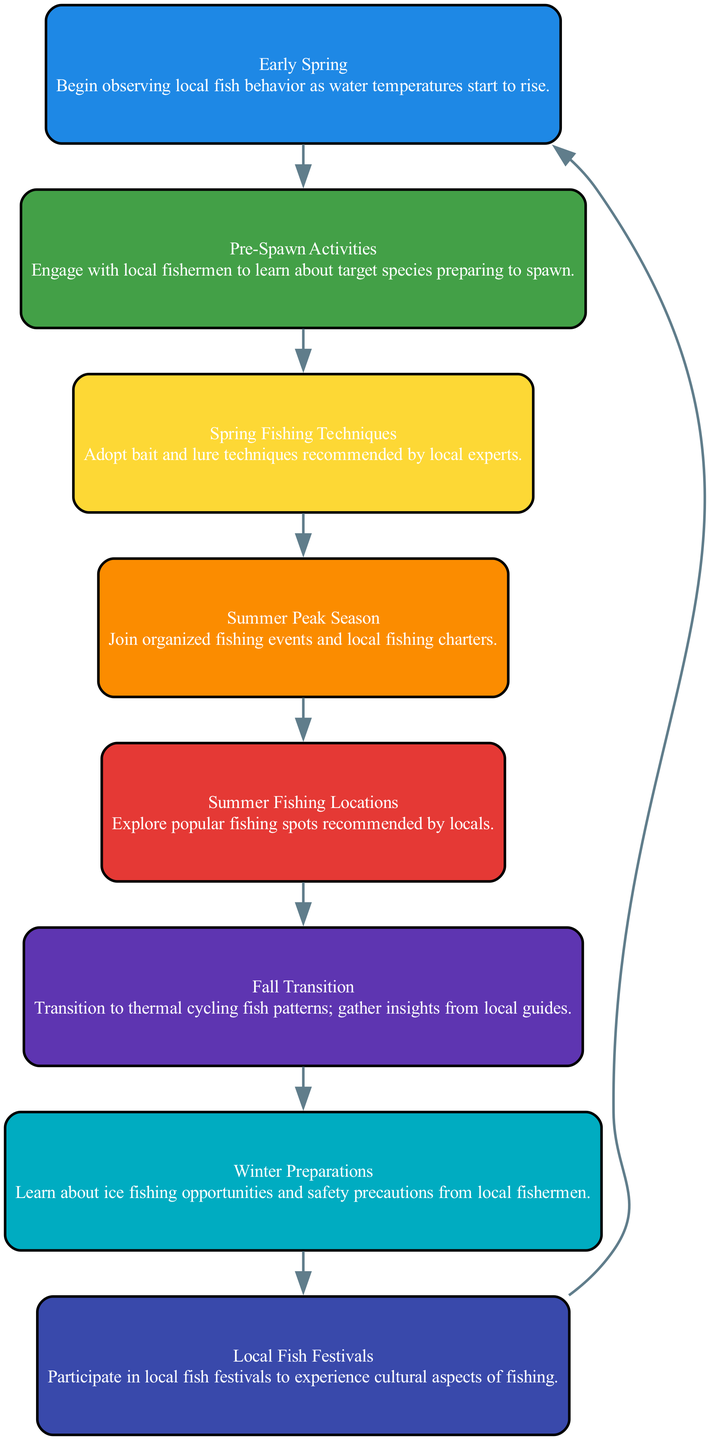What is the last node in the flow chart? The last node listed in the flow chart is "Winter Preparations." It's the final element in the seasonal fishing activity flow.
Answer: Winter Preparations How many nodes are present in the diagram? There are eight nodes in total in the flow chart, each representing a different stage of seasonal fishing activities.
Answer: Eight What follows "Summer Peak Season" in the flow chart? "Summer Fishing Locations" follows "Summer Peak Season," indicating a progression in activities during the summer months.
Answer: Summer Fishing Locations Which activity occurs after "Fall Transition"? After "Fall Transition," the activity is "Winter Preparations," which signifies the upcoming changes as winter approaches.
Answer: Winter Preparations What is the relationship between "Early Spring" and "Pre-Spawn Activities"? "Pre-Spawn Activities" comes directly after "Early Spring," suggesting a sequence where observing fish behavior leads to engaging with local fishermen about spawning fish.
Answer: Sequential relationship How many edges connect the nodes in the diagram? There are eight edges connecting the nodes, as each element flows to the next in the seasonal fishing activity process and wraps around to the first.
Answer: Eight Which two activities are related to summer fishing? "Summer Peak Season" and "Summer Fishing Locations" are related to summer fishing activities, indicating a focus on optimal fishing times and locations during the summer months.
Answer: Summer Peak Season, Summer Fishing Locations What seasonal activity is associated with cultural experiences? "Local Fish Festivals" is associated with cultural experiences, allowing participants to immerse themselves in local fishing culture.
Answer: Local Fish Festivals 